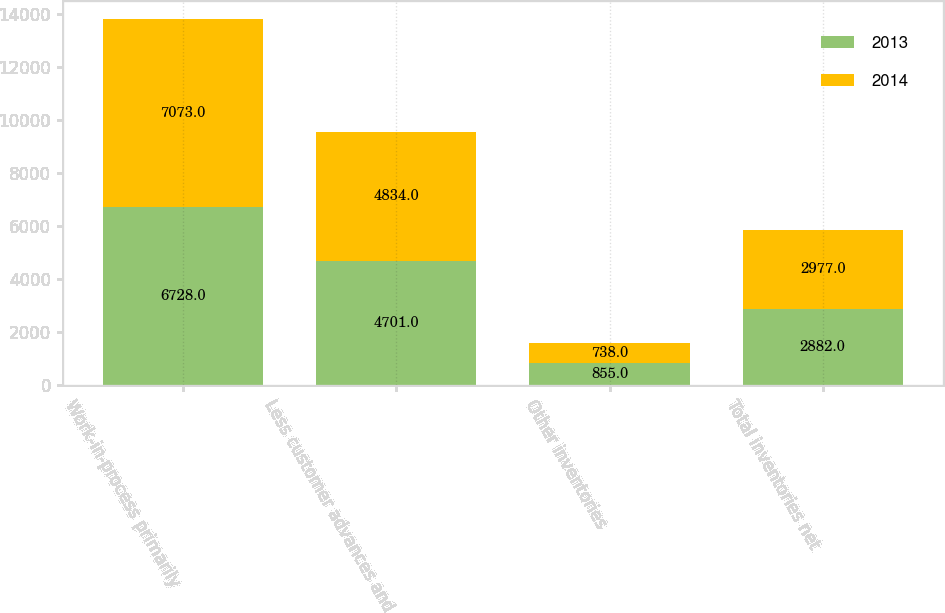Convert chart. <chart><loc_0><loc_0><loc_500><loc_500><stacked_bar_chart><ecel><fcel>Work-in-process primarily<fcel>Less customer advances and<fcel>Other inventories<fcel>Total inventories net<nl><fcel>2013<fcel>6728<fcel>4701<fcel>855<fcel>2882<nl><fcel>2014<fcel>7073<fcel>4834<fcel>738<fcel>2977<nl></chart> 